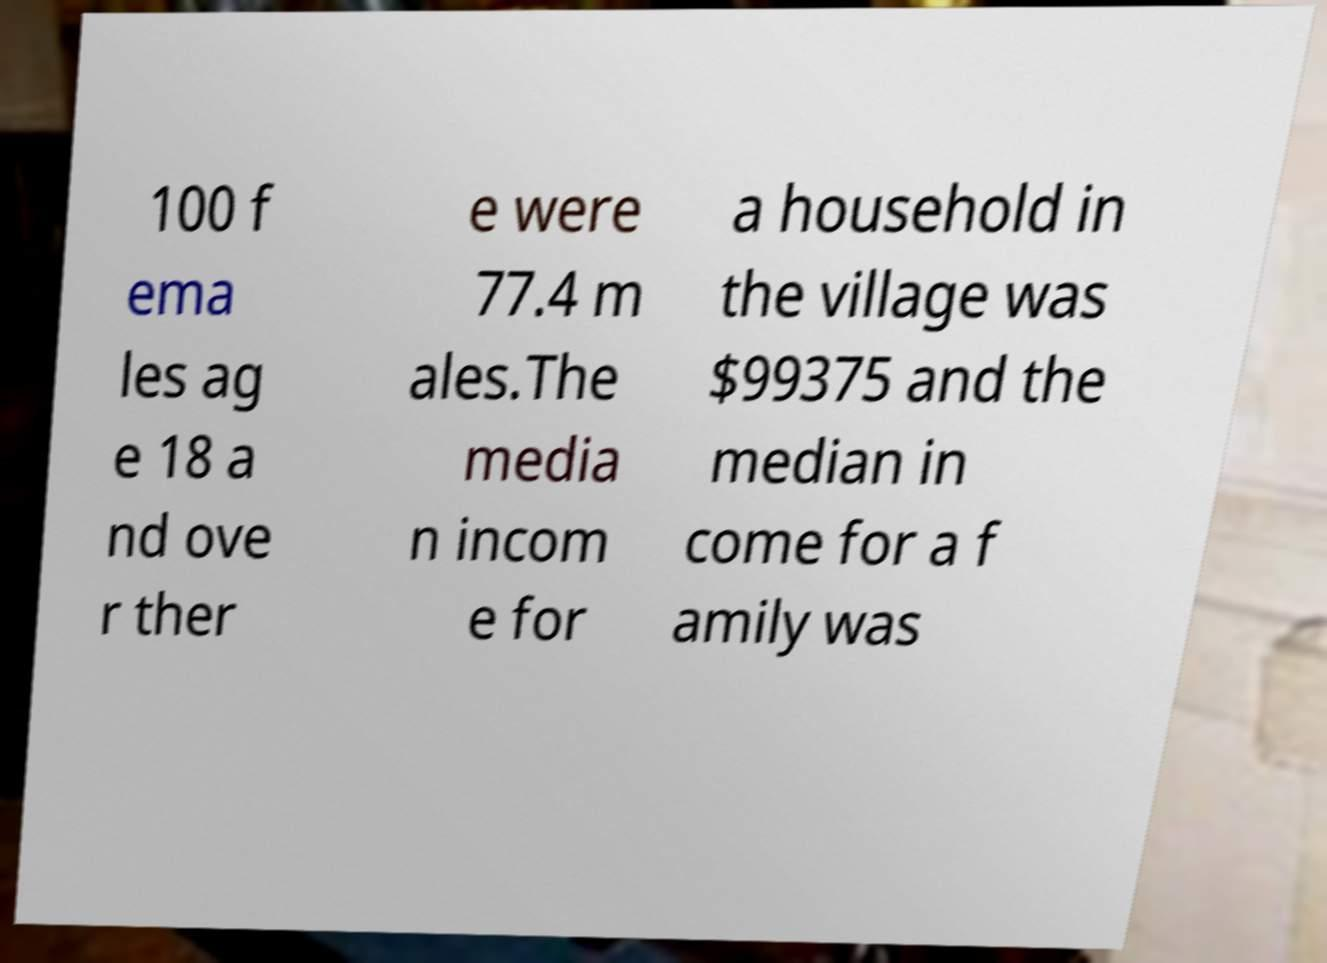What messages or text are displayed in this image? I need them in a readable, typed format. 100 f ema les ag e 18 a nd ove r ther e were 77.4 m ales.The media n incom e for a household in the village was $99375 and the median in come for a f amily was 